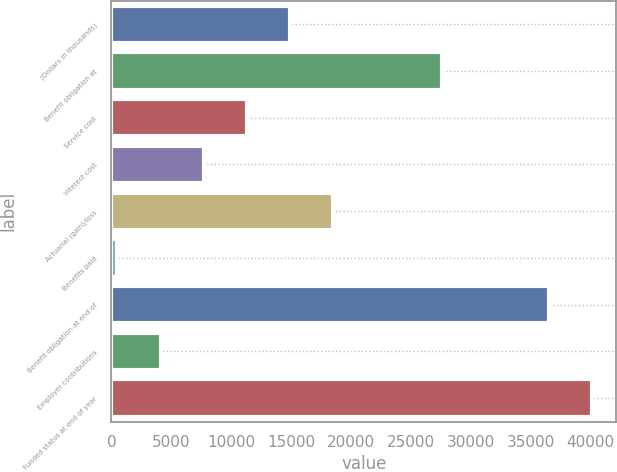Convert chart. <chart><loc_0><loc_0><loc_500><loc_500><bar_chart><fcel>(Dollars in thousands)<fcel>Benefit obligation at<fcel>Service cost<fcel>Interest cost<fcel>Actuarial (gain)/loss<fcel>Benefits paid<fcel>Benefit obligation at end of<fcel>Employer contributions<fcel>Funded status at end of year<nl><fcel>14903.6<fcel>27594<fcel>11303.2<fcel>7702.8<fcel>18504<fcel>502<fcel>36506<fcel>4102.4<fcel>40106.4<nl></chart> 